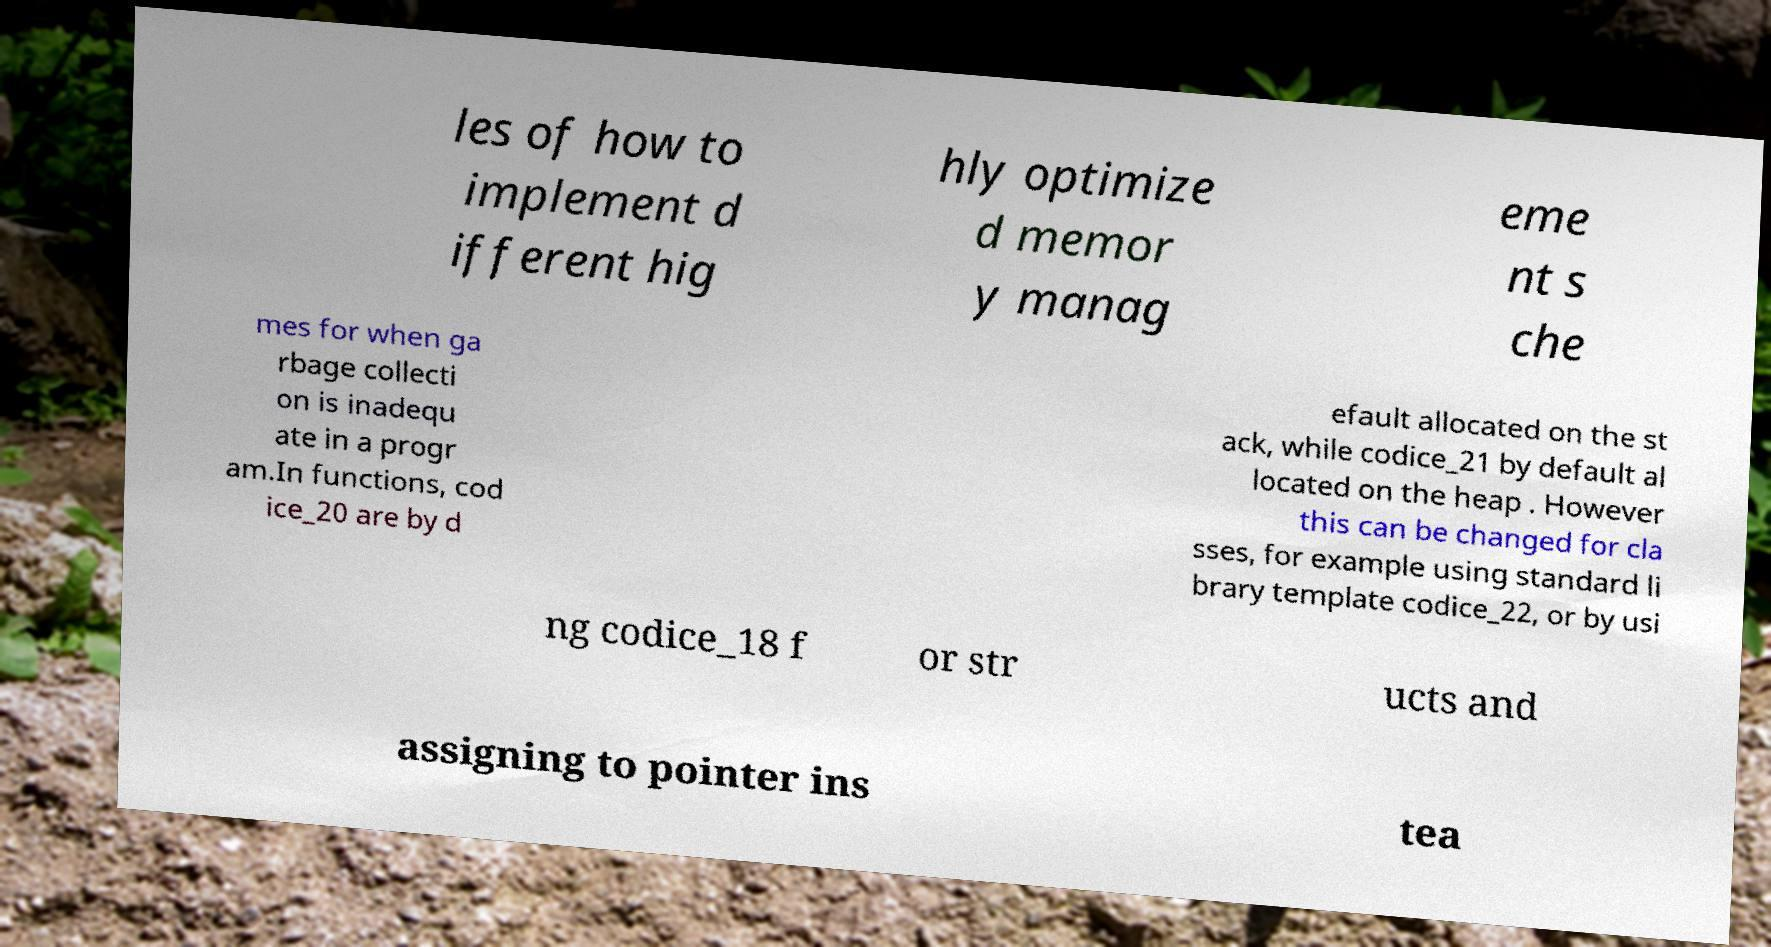What messages or text are displayed in this image? I need them in a readable, typed format. les of how to implement d ifferent hig hly optimize d memor y manag eme nt s che mes for when ga rbage collecti on is inadequ ate in a progr am.In functions, cod ice_20 are by d efault allocated on the st ack, while codice_21 by default al located on the heap . However this can be changed for cla sses, for example using standard li brary template codice_22, or by usi ng codice_18 f or str ucts and assigning to pointer ins tea 